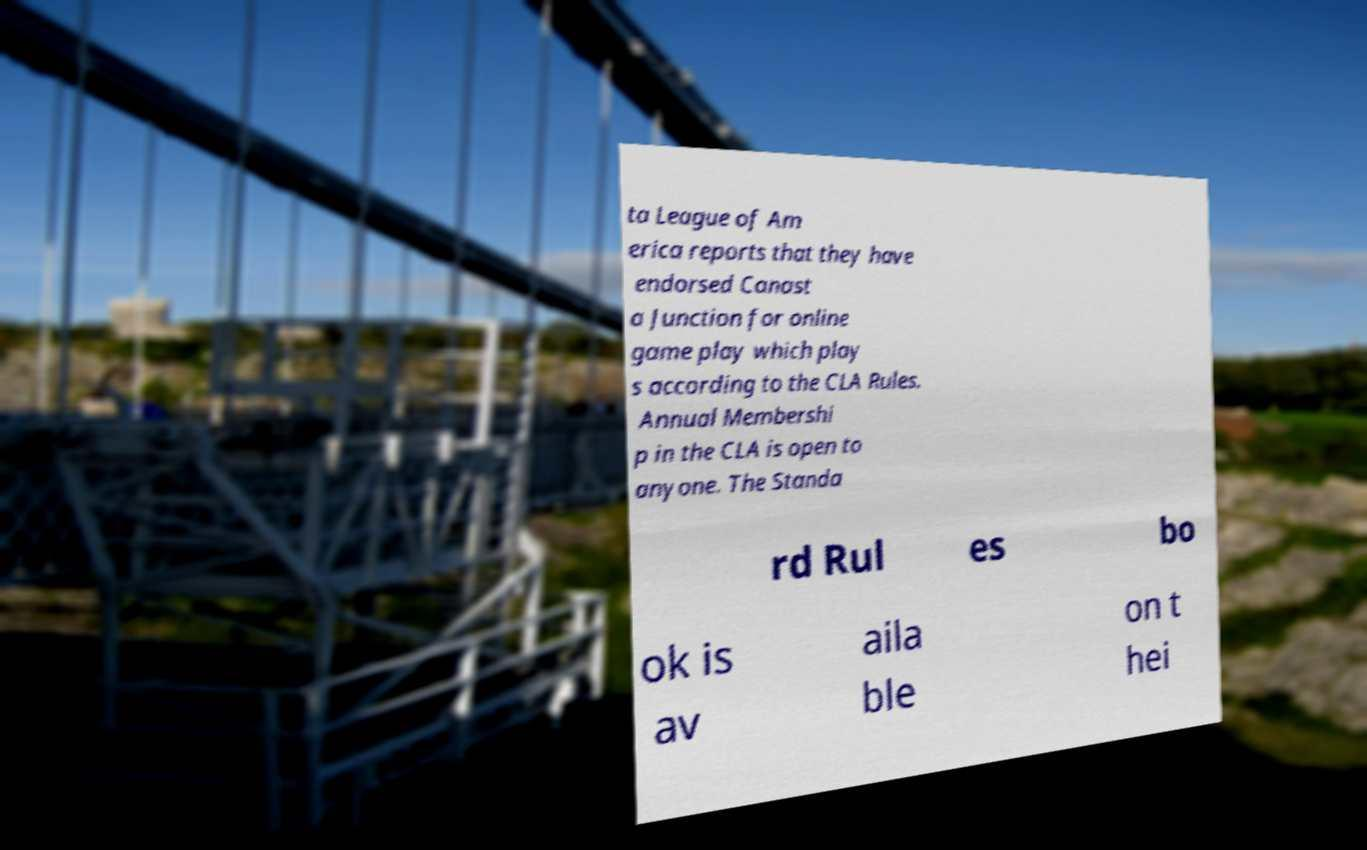I need the written content from this picture converted into text. Can you do that? ta League of Am erica reports that they have endorsed Canast a Junction for online game play which play s according to the CLA Rules. Annual Membershi p in the CLA is open to anyone. The Standa rd Rul es bo ok is av aila ble on t hei 